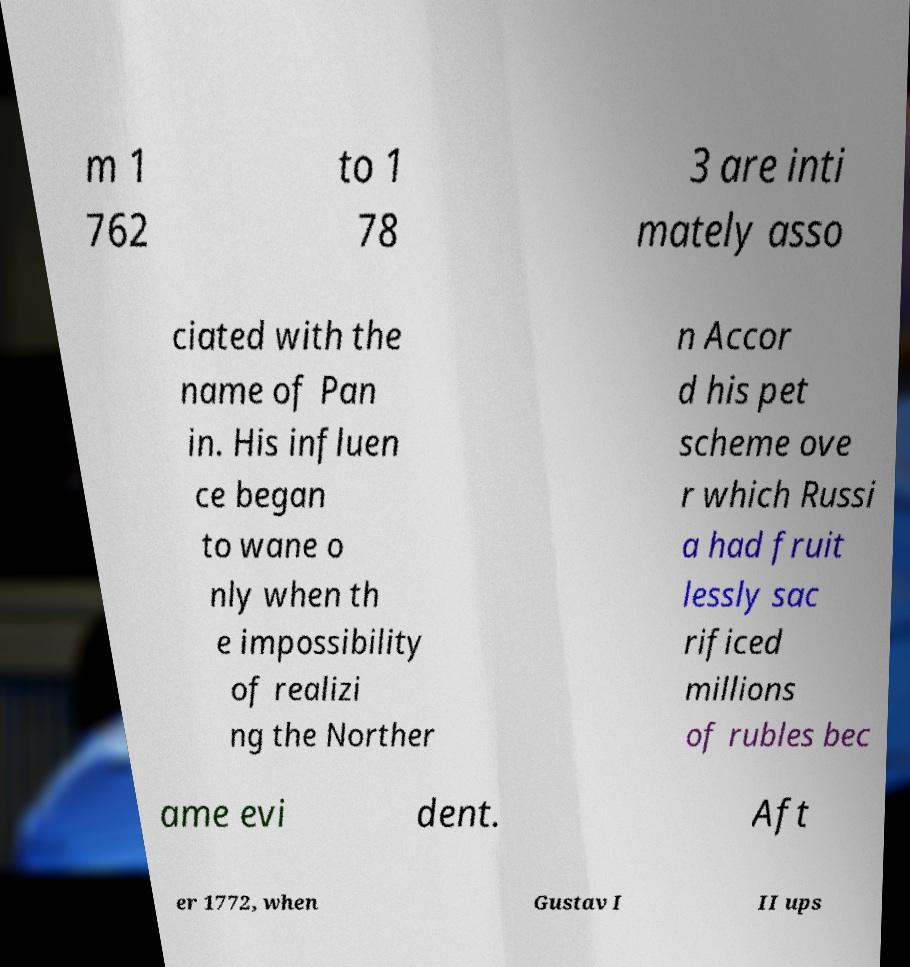What messages or text are displayed in this image? I need them in a readable, typed format. m 1 762 to 1 78 3 are inti mately asso ciated with the name of Pan in. His influen ce began to wane o nly when th e impossibility of realizi ng the Norther n Accor d his pet scheme ove r which Russi a had fruit lessly sac rificed millions of rubles bec ame evi dent. Aft er 1772, when Gustav I II ups 